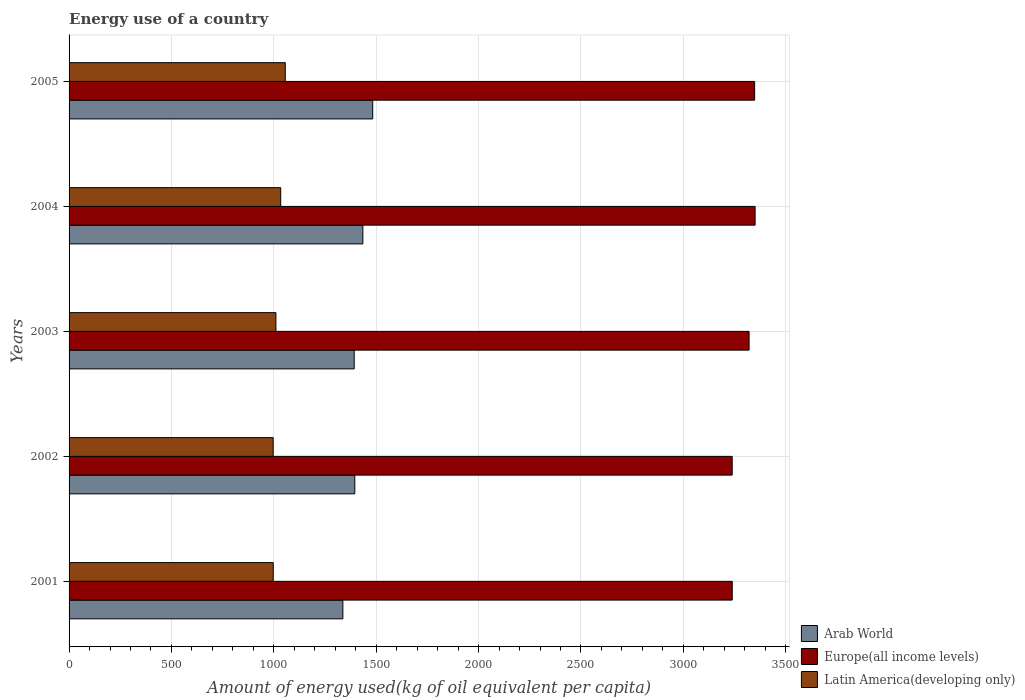How many bars are there on the 5th tick from the top?
Your answer should be compact. 3. What is the amount of energy used in in Arab World in 2001?
Offer a terse response. 1337.2. Across all years, what is the maximum amount of energy used in in Latin America(developing only)?
Your answer should be very brief. 1055.99. Across all years, what is the minimum amount of energy used in in Latin America(developing only)?
Your answer should be compact. 996.82. In which year was the amount of energy used in in Europe(all income levels) maximum?
Provide a succinct answer. 2004. What is the total amount of energy used in in Europe(all income levels) in the graph?
Ensure brevity in your answer.  1.65e+04. What is the difference between the amount of energy used in in Arab World in 2001 and that in 2003?
Your answer should be compact. -55.41. What is the difference between the amount of energy used in in Arab World in 2001 and the amount of energy used in in Europe(all income levels) in 2002?
Provide a succinct answer. -1901.45. What is the average amount of energy used in in Latin America(developing only) per year?
Make the answer very short. 1018.74. In the year 2005, what is the difference between the amount of energy used in in Latin America(developing only) and amount of energy used in in Arab World?
Your answer should be compact. -426.96. In how many years, is the amount of energy used in in Europe(all income levels) greater than 500 kg?
Ensure brevity in your answer.  5. What is the ratio of the amount of energy used in in Arab World in 2003 to that in 2004?
Offer a terse response. 0.97. Is the difference between the amount of energy used in in Latin America(developing only) in 2003 and 2004 greater than the difference between the amount of energy used in in Arab World in 2003 and 2004?
Provide a succinct answer. Yes. What is the difference between the highest and the second highest amount of energy used in in Europe(all income levels)?
Provide a short and direct response. 2.31. What is the difference between the highest and the lowest amount of energy used in in Europe(all income levels)?
Offer a very short reply. 111.96. Is the sum of the amount of energy used in in Europe(all income levels) in 2003 and 2004 greater than the maximum amount of energy used in in Latin America(developing only) across all years?
Your answer should be very brief. Yes. What does the 3rd bar from the top in 2004 represents?
Keep it short and to the point. Arab World. What does the 3rd bar from the bottom in 2004 represents?
Offer a terse response. Latin America(developing only). Where does the legend appear in the graph?
Your answer should be compact. Bottom right. How are the legend labels stacked?
Offer a very short reply. Vertical. What is the title of the graph?
Keep it short and to the point. Energy use of a country. Does "Albania" appear as one of the legend labels in the graph?
Ensure brevity in your answer.  No. What is the label or title of the X-axis?
Give a very brief answer. Amount of energy used(kg of oil equivalent per capita). What is the Amount of energy used(kg of oil equivalent per capita) of Arab World in 2001?
Ensure brevity in your answer.  1337.2. What is the Amount of energy used(kg of oil equivalent per capita) of Europe(all income levels) in 2001?
Make the answer very short. 3238.84. What is the Amount of energy used(kg of oil equivalent per capita) in Latin America(developing only) in 2001?
Provide a short and direct response. 997.14. What is the Amount of energy used(kg of oil equivalent per capita) in Arab World in 2002?
Your answer should be compact. 1395.47. What is the Amount of energy used(kg of oil equivalent per capita) of Europe(all income levels) in 2002?
Offer a very short reply. 3238.65. What is the Amount of energy used(kg of oil equivalent per capita) in Latin America(developing only) in 2002?
Ensure brevity in your answer.  996.82. What is the Amount of energy used(kg of oil equivalent per capita) of Arab World in 2003?
Offer a very short reply. 1392.61. What is the Amount of energy used(kg of oil equivalent per capita) in Europe(all income levels) in 2003?
Ensure brevity in your answer.  3321.23. What is the Amount of energy used(kg of oil equivalent per capita) of Latin America(developing only) in 2003?
Ensure brevity in your answer.  1010.16. What is the Amount of energy used(kg of oil equivalent per capita) in Arab World in 2004?
Offer a terse response. 1434.84. What is the Amount of energy used(kg of oil equivalent per capita) in Europe(all income levels) in 2004?
Your response must be concise. 3350.61. What is the Amount of energy used(kg of oil equivalent per capita) in Latin America(developing only) in 2004?
Offer a very short reply. 1033.59. What is the Amount of energy used(kg of oil equivalent per capita) of Arab World in 2005?
Your answer should be compact. 1482.94. What is the Amount of energy used(kg of oil equivalent per capita) in Europe(all income levels) in 2005?
Ensure brevity in your answer.  3348.29. What is the Amount of energy used(kg of oil equivalent per capita) of Latin America(developing only) in 2005?
Make the answer very short. 1055.99. Across all years, what is the maximum Amount of energy used(kg of oil equivalent per capita) of Arab World?
Provide a succinct answer. 1482.94. Across all years, what is the maximum Amount of energy used(kg of oil equivalent per capita) of Europe(all income levels)?
Provide a short and direct response. 3350.61. Across all years, what is the maximum Amount of energy used(kg of oil equivalent per capita) in Latin America(developing only)?
Keep it short and to the point. 1055.99. Across all years, what is the minimum Amount of energy used(kg of oil equivalent per capita) in Arab World?
Make the answer very short. 1337.2. Across all years, what is the minimum Amount of energy used(kg of oil equivalent per capita) in Europe(all income levels)?
Provide a short and direct response. 3238.65. Across all years, what is the minimum Amount of energy used(kg of oil equivalent per capita) of Latin America(developing only)?
Provide a short and direct response. 996.82. What is the total Amount of energy used(kg of oil equivalent per capita) in Arab World in the graph?
Ensure brevity in your answer.  7043.06. What is the total Amount of energy used(kg of oil equivalent per capita) of Europe(all income levels) in the graph?
Keep it short and to the point. 1.65e+04. What is the total Amount of energy used(kg of oil equivalent per capita) in Latin America(developing only) in the graph?
Your answer should be very brief. 5093.69. What is the difference between the Amount of energy used(kg of oil equivalent per capita) of Arab World in 2001 and that in 2002?
Your answer should be compact. -58.27. What is the difference between the Amount of energy used(kg of oil equivalent per capita) of Europe(all income levels) in 2001 and that in 2002?
Offer a terse response. 0.19. What is the difference between the Amount of energy used(kg of oil equivalent per capita) of Latin America(developing only) in 2001 and that in 2002?
Give a very brief answer. 0.31. What is the difference between the Amount of energy used(kg of oil equivalent per capita) in Arab World in 2001 and that in 2003?
Your answer should be very brief. -55.41. What is the difference between the Amount of energy used(kg of oil equivalent per capita) in Europe(all income levels) in 2001 and that in 2003?
Make the answer very short. -82.39. What is the difference between the Amount of energy used(kg of oil equivalent per capita) in Latin America(developing only) in 2001 and that in 2003?
Your answer should be compact. -13.02. What is the difference between the Amount of energy used(kg of oil equivalent per capita) of Arab World in 2001 and that in 2004?
Your response must be concise. -97.64. What is the difference between the Amount of energy used(kg of oil equivalent per capita) of Europe(all income levels) in 2001 and that in 2004?
Provide a succinct answer. -111.77. What is the difference between the Amount of energy used(kg of oil equivalent per capita) of Latin America(developing only) in 2001 and that in 2004?
Provide a short and direct response. -36.45. What is the difference between the Amount of energy used(kg of oil equivalent per capita) of Arab World in 2001 and that in 2005?
Provide a short and direct response. -145.75. What is the difference between the Amount of energy used(kg of oil equivalent per capita) of Europe(all income levels) in 2001 and that in 2005?
Your answer should be compact. -109.46. What is the difference between the Amount of energy used(kg of oil equivalent per capita) of Latin America(developing only) in 2001 and that in 2005?
Provide a succinct answer. -58.85. What is the difference between the Amount of energy used(kg of oil equivalent per capita) in Arab World in 2002 and that in 2003?
Offer a terse response. 2.86. What is the difference between the Amount of energy used(kg of oil equivalent per capita) of Europe(all income levels) in 2002 and that in 2003?
Offer a very short reply. -82.58. What is the difference between the Amount of energy used(kg of oil equivalent per capita) of Latin America(developing only) in 2002 and that in 2003?
Provide a succinct answer. -13.34. What is the difference between the Amount of energy used(kg of oil equivalent per capita) of Arab World in 2002 and that in 2004?
Offer a very short reply. -39.37. What is the difference between the Amount of energy used(kg of oil equivalent per capita) of Europe(all income levels) in 2002 and that in 2004?
Offer a very short reply. -111.96. What is the difference between the Amount of energy used(kg of oil equivalent per capita) of Latin America(developing only) in 2002 and that in 2004?
Provide a succinct answer. -36.76. What is the difference between the Amount of energy used(kg of oil equivalent per capita) in Arab World in 2002 and that in 2005?
Your response must be concise. -87.47. What is the difference between the Amount of energy used(kg of oil equivalent per capita) in Europe(all income levels) in 2002 and that in 2005?
Offer a terse response. -109.64. What is the difference between the Amount of energy used(kg of oil equivalent per capita) in Latin America(developing only) in 2002 and that in 2005?
Keep it short and to the point. -59.16. What is the difference between the Amount of energy used(kg of oil equivalent per capita) of Arab World in 2003 and that in 2004?
Offer a terse response. -42.23. What is the difference between the Amount of energy used(kg of oil equivalent per capita) of Europe(all income levels) in 2003 and that in 2004?
Keep it short and to the point. -29.38. What is the difference between the Amount of energy used(kg of oil equivalent per capita) of Latin America(developing only) in 2003 and that in 2004?
Your response must be concise. -23.43. What is the difference between the Amount of energy used(kg of oil equivalent per capita) of Arab World in 2003 and that in 2005?
Provide a short and direct response. -90.34. What is the difference between the Amount of energy used(kg of oil equivalent per capita) of Europe(all income levels) in 2003 and that in 2005?
Give a very brief answer. -27.07. What is the difference between the Amount of energy used(kg of oil equivalent per capita) in Latin America(developing only) in 2003 and that in 2005?
Your answer should be compact. -45.83. What is the difference between the Amount of energy used(kg of oil equivalent per capita) in Arab World in 2004 and that in 2005?
Offer a terse response. -48.1. What is the difference between the Amount of energy used(kg of oil equivalent per capita) in Europe(all income levels) in 2004 and that in 2005?
Ensure brevity in your answer.  2.31. What is the difference between the Amount of energy used(kg of oil equivalent per capita) in Latin America(developing only) in 2004 and that in 2005?
Your response must be concise. -22.4. What is the difference between the Amount of energy used(kg of oil equivalent per capita) of Arab World in 2001 and the Amount of energy used(kg of oil equivalent per capita) of Europe(all income levels) in 2002?
Give a very brief answer. -1901.45. What is the difference between the Amount of energy used(kg of oil equivalent per capita) in Arab World in 2001 and the Amount of energy used(kg of oil equivalent per capita) in Latin America(developing only) in 2002?
Your response must be concise. 340.37. What is the difference between the Amount of energy used(kg of oil equivalent per capita) of Europe(all income levels) in 2001 and the Amount of energy used(kg of oil equivalent per capita) of Latin America(developing only) in 2002?
Keep it short and to the point. 2242.01. What is the difference between the Amount of energy used(kg of oil equivalent per capita) of Arab World in 2001 and the Amount of energy used(kg of oil equivalent per capita) of Europe(all income levels) in 2003?
Offer a very short reply. -1984.03. What is the difference between the Amount of energy used(kg of oil equivalent per capita) in Arab World in 2001 and the Amount of energy used(kg of oil equivalent per capita) in Latin America(developing only) in 2003?
Make the answer very short. 327.04. What is the difference between the Amount of energy used(kg of oil equivalent per capita) in Europe(all income levels) in 2001 and the Amount of energy used(kg of oil equivalent per capita) in Latin America(developing only) in 2003?
Make the answer very short. 2228.68. What is the difference between the Amount of energy used(kg of oil equivalent per capita) of Arab World in 2001 and the Amount of energy used(kg of oil equivalent per capita) of Europe(all income levels) in 2004?
Your answer should be compact. -2013.41. What is the difference between the Amount of energy used(kg of oil equivalent per capita) of Arab World in 2001 and the Amount of energy used(kg of oil equivalent per capita) of Latin America(developing only) in 2004?
Provide a succinct answer. 303.61. What is the difference between the Amount of energy used(kg of oil equivalent per capita) in Europe(all income levels) in 2001 and the Amount of energy used(kg of oil equivalent per capita) in Latin America(developing only) in 2004?
Give a very brief answer. 2205.25. What is the difference between the Amount of energy used(kg of oil equivalent per capita) of Arab World in 2001 and the Amount of energy used(kg of oil equivalent per capita) of Europe(all income levels) in 2005?
Ensure brevity in your answer.  -2011.1. What is the difference between the Amount of energy used(kg of oil equivalent per capita) of Arab World in 2001 and the Amount of energy used(kg of oil equivalent per capita) of Latin America(developing only) in 2005?
Offer a very short reply. 281.21. What is the difference between the Amount of energy used(kg of oil equivalent per capita) of Europe(all income levels) in 2001 and the Amount of energy used(kg of oil equivalent per capita) of Latin America(developing only) in 2005?
Give a very brief answer. 2182.85. What is the difference between the Amount of energy used(kg of oil equivalent per capita) of Arab World in 2002 and the Amount of energy used(kg of oil equivalent per capita) of Europe(all income levels) in 2003?
Offer a terse response. -1925.76. What is the difference between the Amount of energy used(kg of oil equivalent per capita) in Arab World in 2002 and the Amount of energy used(kg of oil equivalent per capita) in Latin America(developing only) in 2003?
Your response must be concise. 385.31. What is the difference between the Amount of energy used(kg of oil equivalent per capita) in Europe(all income levels) in 2002 and the Amount of energy used(kg of oil equivalent per capita) in Latin America(developing only) in 2003?
Provide a succinct answer. 2228.49. What is the difference between the Amount of energy used(kg of oil equivalent per capita) in Arab World in 2002 and the Amount of energy used(kg of oil equivalent per capita) in Europe(all income levels) in 2004?
Offer a terse response. -1955.14. What is the difference between the Amount of energy used(kg of oil equivalent per capita) in Arab World in 2002 and the Amount of energy used(kg of oil equivalent per capita) in Latin America(developing only) in 2004?
Offer a terse response. 361.88. What is the difference between the Amount of energy used(kg of oil equivalent per capita) in Europe(all income levels) in 2002 and the Amount of energy used(kg of oil equivalent per capita) in Latin America(developing only) in 2004?
Make the answer very short. 2205.06. What is the difference between the Amount of energy used(kg of oil equivalent per capita) in Arab World in 2002 and the Amount of energy used(kg of oil equivalent per capita) in Europe(all income levels) in 2005?
Offer a very short reply. -1952.83. What is the difference between the Amount of energy used(kg of oil equivalent per capita) in Arab World in 2002 and the Amount of energy used(kg of oil equivalent per capita) in Latin America(developing only) in 2005?
Your answer should be compact. 339.48. What is the difference between the Amount of energy used(kg of oil equivalent per capita) of Europe(all income levels) in 2002 and the Amount of energy used(kg of oil equivalent per capita) of Latin America(developing only) in 2005?
Your response must be concise. 2182.66. What is the difference between the Amount of energy used(kg of oil equivalent per capita) of Arab World in 2003 and the Amount of energy used(kg of oil equivalent per capita) of Europe(all income levels) in 2004?
Your answer should be compact. -1958. What is the difference between the Amount of energy used(kg of oil equivalent per capita) in Arab World in 2003 and the Amount of energy used(kg of oil equivalent per capita) in Latin America(developing only) in 2004?
Make the answer very short. 359.02. What is the difference between the Amount of energy used(kg of oil equivalent per capita) in Europe(all income levels) in 2003 and the Amount of energy used(kg of oil equivalent per capita) in Latin America(developing only) in 2004?
Provide a succinct answer. 2287.64. What is the difference between the Amount of energy used(kg of oil equivalent per capita) in Arab World in 2003 and the Amount of energy used(kg of oil equivalent per capita) in Europe(all income levels) in 2005?
Your response must be concise. -1955.69. What is the difference between the Amount of energy used(kg of oil equivalent per capita) in Arab World in 2003 and the Amount of energy used(kg of oil equivalent per capita) in Latin America(developing only) in 2005?
Your answer should be compact. 336.62. What is the difference between the Amount of energy used(kg of oil equivalent per capita) in Europe(all income levels) in 2003 and the Amount of energy used(kg of oil equivalent per capita) in Latin America(developing only) in 2005?
Make the answer very short. 2265.24. What is the difference between the Amount of energy used(kg of oil equivalent per capita) in Arab World in 2004 and the Amount of energy used(kg of oil equivalent per capita) in Europe(all income levels) in 2005?
Ensure brevity in your answer.  -1913.45. What is the difference between the Amount of energy used(kg of oil equivalent per capita) in Arab World in 2004 and the Amount of energy used(kg of oil equivalent per capita) in Latin America(developing only) in 2005?
Make the answer very short. 378.85. What is the difference between the Amount of energy used(kg of oil equivalent per capita) of Europe(all income levels) in 2004 and the Amount of energy used(kg of oil equivalent per capita) of Latin America(developing only) in 2005?
Your answer should be very brief. 2294.62. What is the average Amount of energy used(kg of oil equivalent per capita) in Arab World per year?
Offer a very short reply. 1408.61. What is the average Amount of energy used(kg of oil equivalent per capita) of Europe(all income levels) per year?
Keep it short and to the point. 3299.52. What is the average Amount of energy used(kg of oil equivalent per capita) in Latin America(developing only) per year?
Ensure brevity in your answer.  1018.74. In the year 2001, what is the difference between the Amount of energy used(kg of oil equivalent per capita) in Arab World and Amount of energy used(kg of oil equivalent per capita) in Europe(all income levels)?
Offer a terse response. -1901.64. In the year 2001, what is the difference between the Amount of energy used(kg of oil equivalent per capita) of Arab World and Amount of energy used(kg of oil equivalent per capita) of Latin America(developing only)?
Your answer should be very brief. 340.06. In the year 2001, what is the difference between the Amount of energy used(kg of oil equivalent per capita) in Europe(all income levels) and Amount of energy used(kg of oil equivalent per capita) in Latin America(developing only)?
Make the answer very short. 2241.7. In the year 2002, what is the difference between the Amount of energy used(kg of oil equivalent per capita) of Arab World and Amount of energy used(kg of oil equivalent per capita) of Europe(all income levels)?
Ensure brevity in your answer.  -1843.18. In the year 2002, what is the difference between the Amount of energy used(kg of oil equivalent per capita) of Arab World and Amount of energy used(kg of oil equivalent per capita) of Latin America(developing only)?
Give a very brief answer. 398.65. In the year 2002, what is the difference between the Amount of energy used(kg of oil equivalent per capita) in Europe(all income levels) and Amount of energy used(kg of oil equivalent per capita) in Latin America(developing only)?
Provide a succinct answer. 2241.83. In the year 2003, what is the difference between the Amount of energy used(kg of oil equivalent per capita) in Arab World and Amount of energy used(kg of oil equivalent per capita) in Europe(all income levels)?
Keep it short and to the point. -1928.62. In the year 2003, what is the difference between the Amount of energy used(kg of oil equivalent per capita) of Arab World and Amount of energy used(kg of oil equivalent per capita) of Latin America(developing only)?
Ensure brevity in your answer.  382.45. In the year 2003, what is the difference between the Amount of energy used(kg of oil equivalent per capita) in Europe(all income levels) and Amount of energy used(kg of oil equivalent per capita) in Latin America(developing only)?
Your response must be concise. 2311.07. In the year 2004, what is the difference between the Amount of energy used(kg of oil equivalent per capita) of Arab World and Amount of energy used(kg of oil equivalent per capita) of Europe(all income levels)?
Give a very brief answer. -1915.77. In the year 2004, what is the difference between the Amount of energy used(kg of oil equivalent per capita) of Arab World and Amount of energy used(kg of oil equivalent per capita) of Latin America(developing only)?
Provide a short and direct response. 401.25. In the year 2004, what is the difference between the Amount of energy used(kg of oil equivalent per capita) of Europe(all income levels) and Amount of energy used(kg of oil equivalent per capita) of Latin America(developing only)?
Offer a very short reply. 2317.02. In the year 2005, what is the difference between the Amount of energy used(kg of oil equivalent per capita) of Arab World and Amount of energy used(kg of oil equivalent per capita) of Europe(all income levels)?
Ensure brevity in your answer.  -1865.35. In the year 2005, what is the difference between the Amount of energy used(kg of oil equivalent per capita) of Arab World and Amount of energy used(kg of oil equivalent per capita) of Latin America(developing only)?
Make the answer very short. 426.96. In the year 2005, what is the difference between the Amount of energy used(kg of oil equivalent per capita) of Europe(all income levels) and Amount of energy used(kg of oil equivalent per capita) of Latin America(developing only)?
Your answer should be very brief. 2292.31. What is the ratio of the Amount of energy used(kg of oil equivalent per capita) of Arab World in 2001 to that in 2002?
Make the answer very short. 0.96. What is the ratio of the Amount of energy used(kg of oil equivalent per capita) in Europe(all income levels) in 2001 to that in 2002?
Provide a short and direct response. 1. What is the ratio of the Amount of energy used(kg of oil equivalent per capita) of Arab World in 2001 to that in 2003?
Make the answer very short. 0.96. What is the ratio of the Amount of energy used(kg of oil equivalent per capita) in Europe(all income levels) in 2001 to that in 2003?
Your response must be concise. 0.98. What is the ratio of the Amount of energy used(kg of oil equivalent per capita) of Latin America(developing only) in 2001 to that in 2003?
Keep it short and to the point. 0.99. What is the ratio of the Amount of energy used(kg of oil equivalent per capita) in Arab World in 2001 to that in 2004?
Keep it short and to the point. 0.93. What is the ratio of the Amount of energy used(kg of oil equivalent per capita) in Europe(all income levels) in 2001 to that in 2004?
Provide a short and direct response. 0.97. What is the ratio of the Amount of energy used(kg of oil equivalent per capita) in Latin America(developing only) in 2001 to that in 2004?
Ensure brevity in your answer.  0.96. What is the ratio of the Amount of energy used(kg of oil equivalent per capita) in Arab World in 2001 to that in 2005?
Provide a succinct answer. 0.9. What is the ratio of the Amount of energy used(kg of oil equivalent per capita) in Europe(all income levels) in 2001 to that in 2005?
Offer a very short reply. 0.97. What is the ratio of the Amount of energy used(kg of oil equivalent per capita) of Latin America(developing only) in 2001 to that in 2005?
Make the answer very short. 0.94. What is the ratio of the Amount of energy used(kg of oil equivalent per capita) in Arab World in 2002 to that in 2003?
Provide a short and direct response. 1. What is the ratio of the Amount of energy used(kg of oil equivalent per capita) in Europe(all income levels) in 2002 to that in 2003?
Your response must be concise. 0.98. What is the ratio of the Amount of energy used(kg of oil equivalent per capita) in Latin America(developing only) in 2002 to that in 2003?
Provide a short and direct response. 0.99. What is the ratio of the Amount of energy used(kg of oil equivalent per capita) in Arab World in 2002 to that in 2004?
Offer a terse response. 0.97. What is the ratio of the Amount of energy used(kg of oil equivalent per capita) of Europe(all income levels) in 2002 to that in 2004?
Offer a terse response. 0.97. What is the ratio of the Amount of energy used(kg of oil equivalent per capita) in Latin America(developing only) in 2002 to that in 2004?
Your response must be concise. 0.96. What is the ratio of the Amount of energy used(kg of oil equivalent per capita) in Arab World in 2002 to that in 2005?
Offer a very short reply. 0.94. What is the ratio of the Amount of energy used(kg of oil equivalent per capita) in Europe(all income levels) in 2002 to that in 2005?
Your answer should be very brief. 0.97. What is the ratio of the Amount of energy used(kg of oil equivalent per capita) of Latin America(developing only) in 2002 to that in 2005?
Make the answer very short. 0.94. What is the ratio of the Amount of energy used(kg of oil equivalent per capita) of Arab World in 2003 to that in 2004?
Your answer should be very brief. 0.97. What is the ratio of the Amount of energy used(kg of oil equivalent per capita) in Latin America(developing only) in 2003 to that in 2004?
Provide a succinct answer. 0.98. What is the ratio of the Amount of energy used(kg of oil equivalent per capita) of Arab World in 2003 to that in 2005?
Give a very brief answer. 0.94. What is the ratio of the Amount of energy used(kg of oil equivalent per capita) in Europe(all income levels) in 2003 to that in 2005?
Make the answer very short. 0.99. What is the ratio of the Amount of energy used(kg of oil equivalent per capita) of Latin America(developing only) in 2003 to that in 2005?
Give a very brief answer. 0.96. What is the ratio of the Amount of energy used(kg of oil equivalent per capita) in Arab World in 2004 to that in 2005?
Provide a succinct answer. 0.97. What is the ratio of the Amount of energy used(kg of oil equivalent per capita) in Europe(all income levels) in 2004 to that in 2005?
Give a very brief answer. 1. What is the ratio of the Amount of energy used(kg of oil equivalent per capita) in Latin America(developing only) in 2004 to that in 2005?
Provide a short and direct response. 0.98. What is the difference between the highest and the second highest Amount of energy used(kg of oil equivalent per capita) of Arab World?
Offer a very short reply. 48.1. What is the difference between the highest and the second highest Amount of energy used(kg of oil equivalent per capita) of Europe(all income levels)?
Your answer should be very brief. 2.31. What is the difference between the highest and the second highest Amount of energy used(kg of oil equivalent per capita) of Latin America(developing only)?
Offer a very short reply. 22.4. What is the difference between the highest and the lowest Amount of energy used(kg of oil equivalent per capita) of Arab World?
Your answer should be compact. 145.75. What is the difference between the highest and the lowest Amount of energy used(kg of oil equivalent per capita) of Europe(all income levels)?
Ensure brevity in your answer.  111.96. What is the difference between the highest and the lowest Amount of energy used(kg of oil equivalent per capita) of Latin America(developing only)?
Keep it short and to the point. 59.16. 